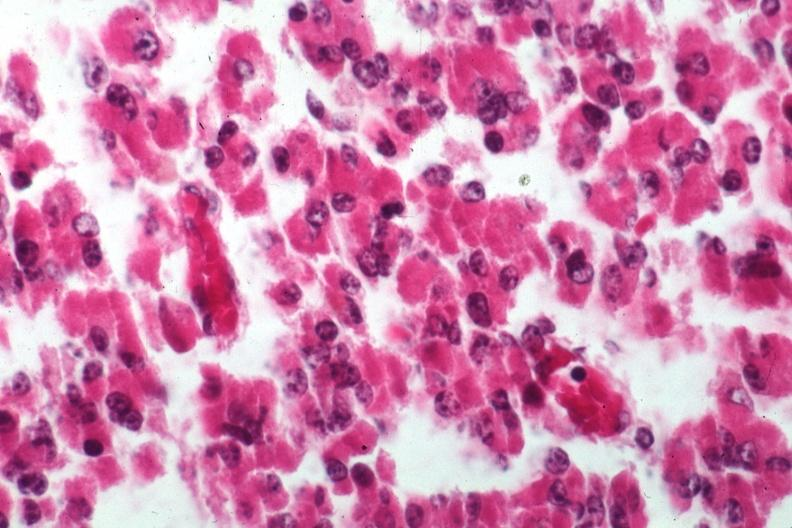what is present?
Answer the question using a single word or phrase. Pituitary 